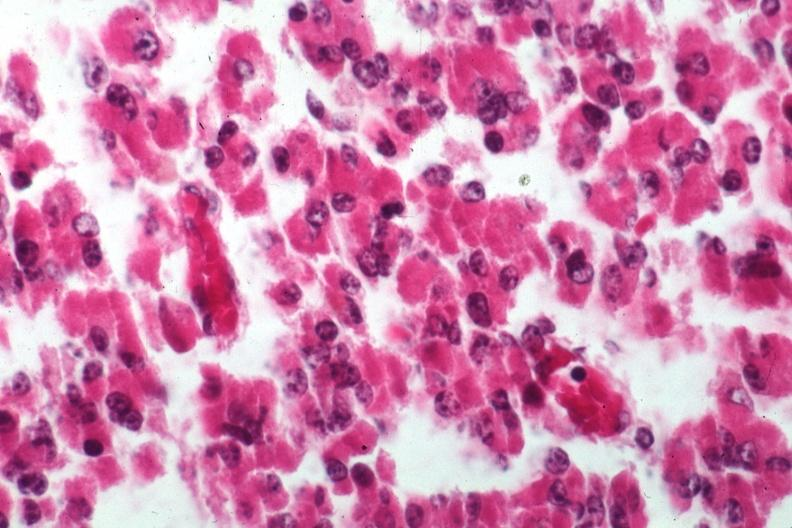what is present?
Answer the question using a single word or phrase. Pituitary 